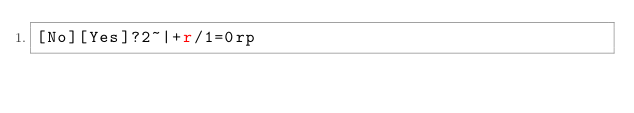<code> <loc_0><loc_0><loc_500><loc_500><_dc_>[No][Yes]?2~|+r/1=0rp</code> 